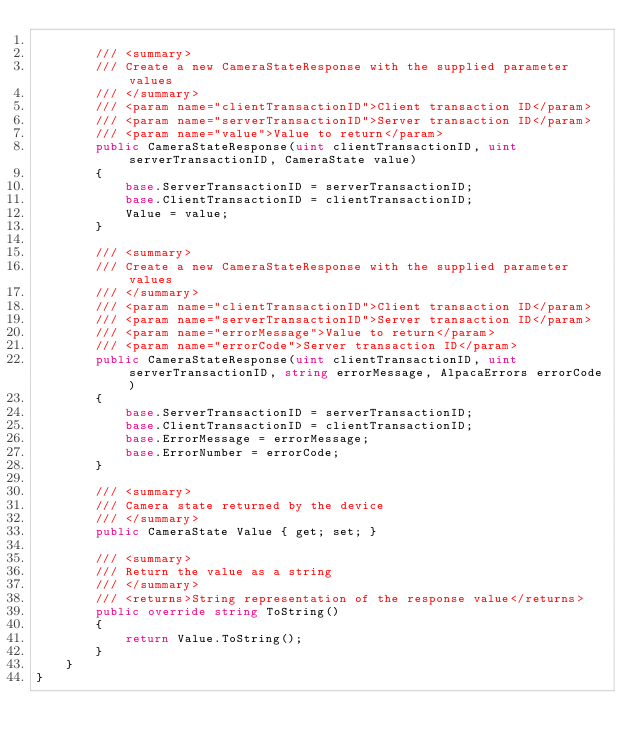Convert code to text. <code><loc_0><loc_0><loc_500><loc_500><_C#_>
        /// <summary>
        /// Create a new CameraStateResponse with the supplied parameter values
        /// </summary>
        /// <param name="clientTransactionID">Client transaction ID</param>
        /// <param name="serverTransactionID">Server transaction ID</param>
        /// <param name="value">Value to return</param>
        public CameraStateResponse(uint clientTransactionID, uint serverTransactionID, CameraState value)
        {
            base.ServerTransactionID = serverTransactionID;
            base.ClientTransactionID = clientTransactionID;
            Value = value;
        }

        /// <summary>
        /// Create a new CameraStateResponse with the supplied parameter values
        /// </summary>
        /// <param name="clientTransactionID">Client transaction ID</param>
        /// <param name="serverTransactionID">Server transaction ID</param>
        /// <param name="errorMessage">Value to return</param>
        /// <param name="errorCode">Server transaction ID</param>
        public CameraStateResponse(uint clientTransactionID, uint serverTransactionID, string errorMessage, AlpacaErrors errorCode)
        {
            base.ServerTransactionID = serverTransactionID;
            base.ClientTransactionID = clientTransactionID;
            base.ErrorMessage = errorMessage;
            base.ErrorNumber = errorCode;
        }

        /// <summary>
        /// Camera state returned by the device
        /// </summary>
        public CameraState Value { get; set; }

        /// <summary>
        /// Return the value as a string
        /// </summary>
        /// <returns>String representation of the response value</returns>
        public override string ToString()
        {
            return Value.ToString();
        }
    }
}</code> 